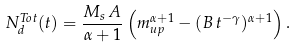Convert formula to latex. <formula><loc_0><loc_0><loc_500><loc_500>N ^ { T o t } _ { d } ( t ) = \frac { M _ { s } \, A } { \alpha + 1 } \left ( m _ { u p } ^ { \alpha + 1 } - ( B \, t ^ { - \gamma } ) ^ { \alpha + 1 } \right ) .</formula> 